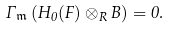<formula> <loc_0><loc_0><loc_500><loc_500>\Gamma _ { \mathfrak { m } } \left ( H _ { 0 } ( F ) \otimes _ { R } B \right ) = 0 .</formula> 